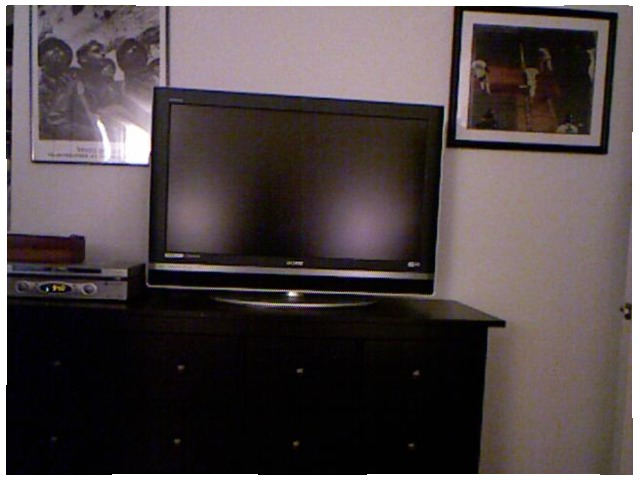<image>
Is there a tv on the table? Yes. Looking at the image, I can see the tv is positioned on top of the table, with the table providing support. Is the photo behind the tv? Yes. From this viewpoint, the photo is positioned behind the tv, with the tv partially or fully occluding the photo. Is there a tv behind the dresser? No. The tv is not behind the dresser. From this viewpoint, the tv appears to be positioned elsewhere in the scene. Where is the tv in relation to the picture? Is it behind the picture? No. The tv is not behind the picture. From this viewpoint, the tv appears to be positioned elsewhere in the scene. Where is the tv in relation to the drawer? Is it above the drawer? No. The tv is not positioned above the drawer. The vertical arrangement shows a different relationship. Where is the picture in relation to the television? Is it to the right of the television? Yes. From this viewpoint, the picture is positioned to the right side relative to the television. 